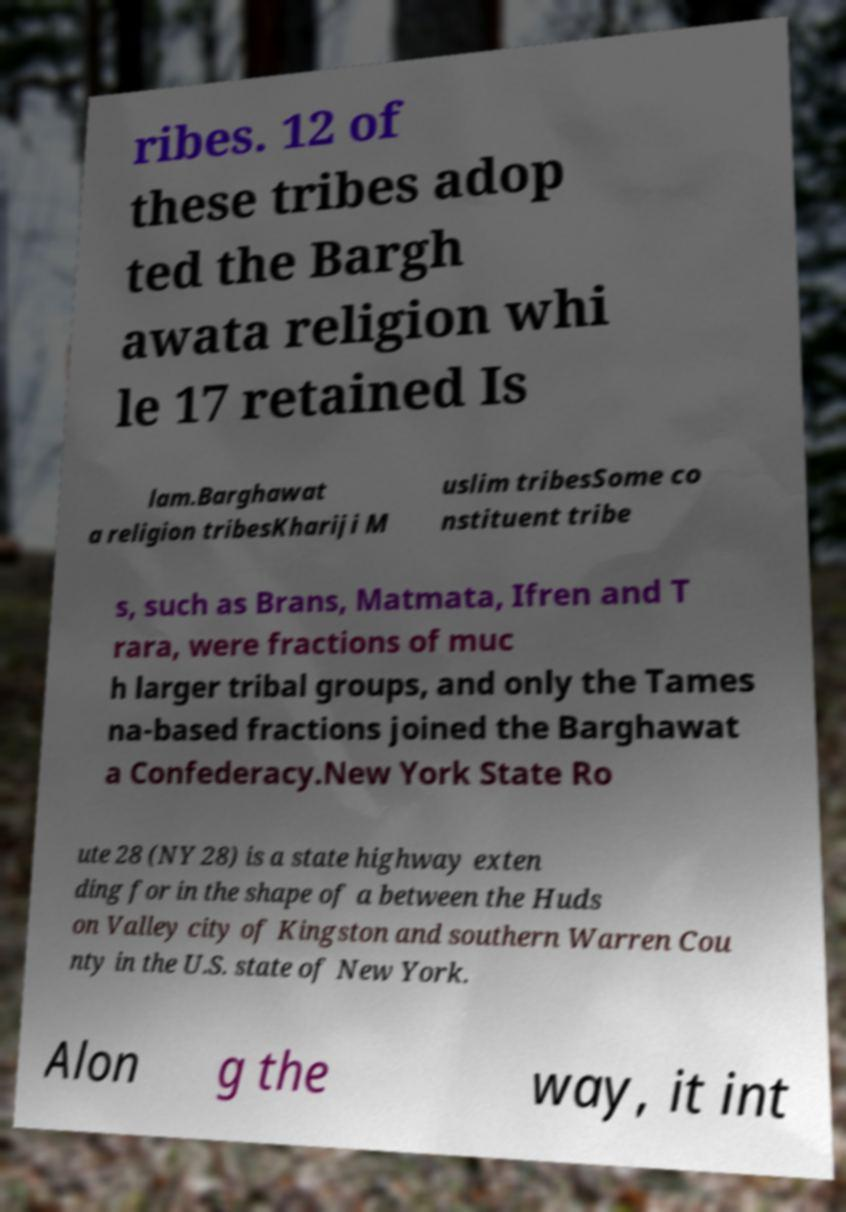Can you read and provide the text displayed in the image?This photo seems to have some interesting text. Can you extract and type it out for me? ribes. 12 of these tribes adop ted the Bargh awata religion whi le 17 retained Is lam.Barghawat a religion tribesKhariji M uslim tribesSome co nstituent tribe s, such as Brans, Matmata, Ifren and T rara, were fractions of muc h larger tribal groups, and only the Tames na-based fractions joined the Barghawat a Confederacy.New York State Ro ute 28 (NY 28) is a state highway exten ding for in the shape of a between the Huds on Valley city of Kingston and southern Warren Cou nty in the U.S. state of New York. Alon g the way, it int 